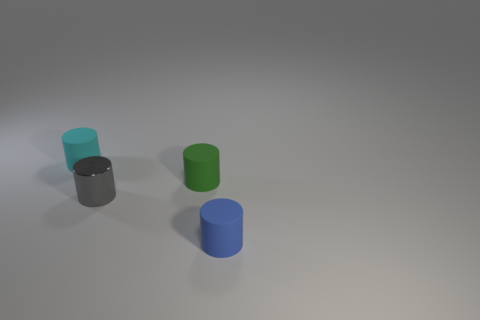Is there anything else that is made of the same material as the tiny gray object?
Keep it short and to the point. No. There is a matte object to the left of the green thing behind the tiny gray cylinder to the left of the green cylinder; what is its size?
Your answer should be compact. Small. Does the green cylinder have the same size as the blue rubber cylinder?
Make the answer very short. Yes. What number of objects are either blue rubber cylinders or cyan objects?
Give a very brief answer. 2. There is a object on the left side of the tiny gray metallic thing that is in front of the tiny green matte cylinder; what is its size?
Provide a short and direct response. Small. The blue matte cylinder is what size?
Offer a terse response. Small. What shape is the small rubber thing that is left of the small blue rubber cylinder and on the right side of the small cyan matte cylinder?
Give a very brief answer. Cylinder. What is the color of the metal object that is the same shape as the tiny cyan matte thing?
Give a very brief answer. Gray. What number of things are small rubber cylinders that are on the right side of the tiny green object or objects that are on the right side of the small green rubber cylinder?
Keep it short and to the point. 1. How many brown spheres have the same material as the cyan thing?
Your answer should be very brief. 0. 